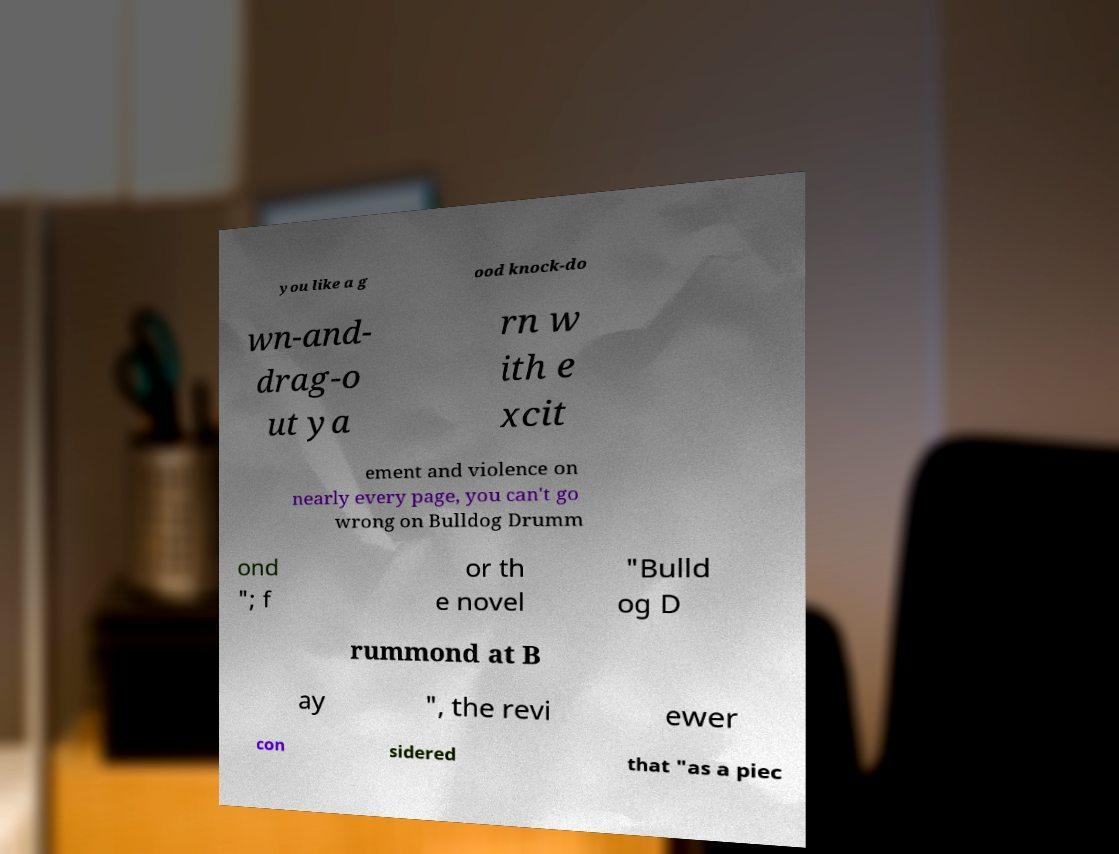Please identify and transcribe the text found in this image. you like a g ood knock-do wn-and- drag-o ut ya rn w ith e xcit ement and violence on nearly every page, you can't go wrong on Bulldog Drumm ond "; f or th e novel "Bulld og D rummond at B ay ", the revi ewer con sidered that "as a piec 